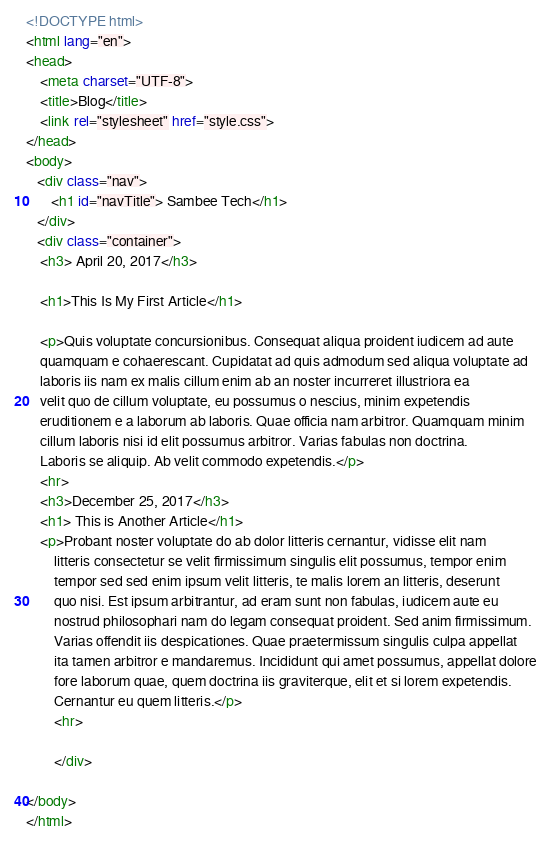Convert code to text. <code><loc_0><loc_0><loc_500><loc_500><_HTML_><!DOCTYPE html>
<html lang="en">
<head>
    <meta charset="UTF-8">
    <title>Blog</title>
    <link rel="stylesheet" href="style.css">
</head>
<body>
   <div class="nav">
       <h1 id="navTitle"> Sambee Tech</h1>
   </div>
   <div class="container">
    <h3> April 20, 2017</h3>
    
    <h1>This Is My First Article</h1>
    
    <p>Quis voluptate concursionibus. Consequat aliqua proident iudicem ad aute 
    quamquam e cohaerescant. Cupidatat ad quis admodum sed aliqua voluptate ad 
    laboris iis nam ex malis cillum enim ab an noster incurreret illustriora ea 
    velit quo de cillum voluptate, eu possumus o nescius, minim expetendis 
    eruditionem e a laborum ab laboris. Quae officia nam arbitror. Quamquam minim 
    cillum laboris nisi id elit possumus arbitror. Varias fabulas non doctrina. 
    Laboris se aliquip. Ab velit commodo expetendis.</p>
    <hr>
    <h3>December 25, 2017</h3>
    <h1> This is Another Article</h1>
    <p>Probant noster voluptate do ab dolor litteris cernantur, vidisse elit nam 
        litteris consectetur se velit firmissimum singulis elit possumus, tempor enim 
        tempor sed sed enim ipsum velit litteris, te malis lorem an litteris, deserunt 
        quo nisi. Est ipsum arbitrantur, ad eram sunt non fabulas, iudicem aute eu 
        nostrud philosophari nam do legam consequat proident. Sed anim firmissimum. 
        Varias offendit iis despicationes. Quae praetermissum singulis culpa appellat 
        ita tamen arbitror e mandaremus. Incididunt qui amet possumus, appellat dolore 
        fore laborum quae, quem doctrina iis graviterque, elit et si lorem expetendis. 
        Cernantur eu quem litteris.</p>
        <hr>
       
        </div>
        
</body>
</html></code> 